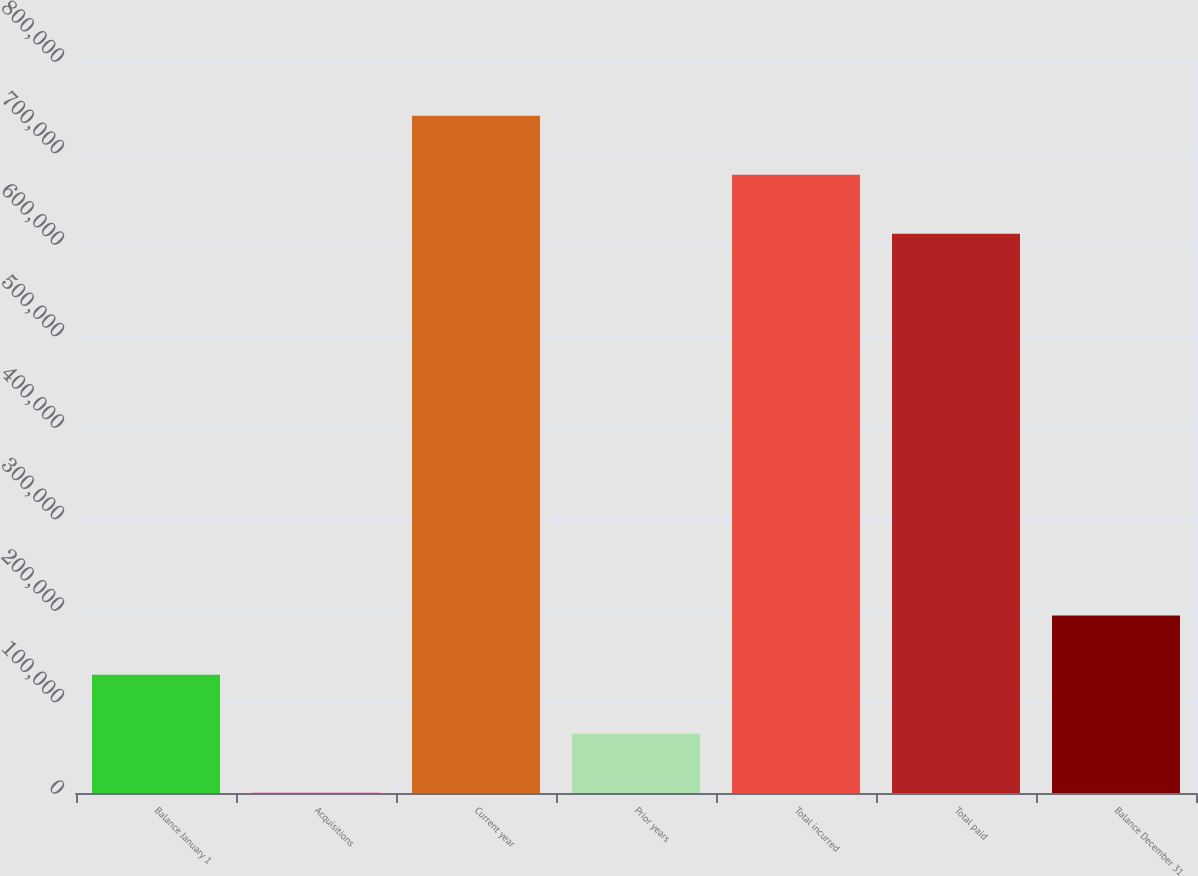<chart> <loc_0><loc_0><loc_500><loc_500><bar_chart><fcel>Balance January 1<fcel>Acquisitions<fcel>Current year<fcel>Prior years<fcel>Total incurred<fcel>Total paid<fcel>Balance December 31<nl><fcel>129364<fcel>335<fcel>740168<fcel>64849.7<fcel>675654<fcel>611139<fcel>193879<nl></chart> 